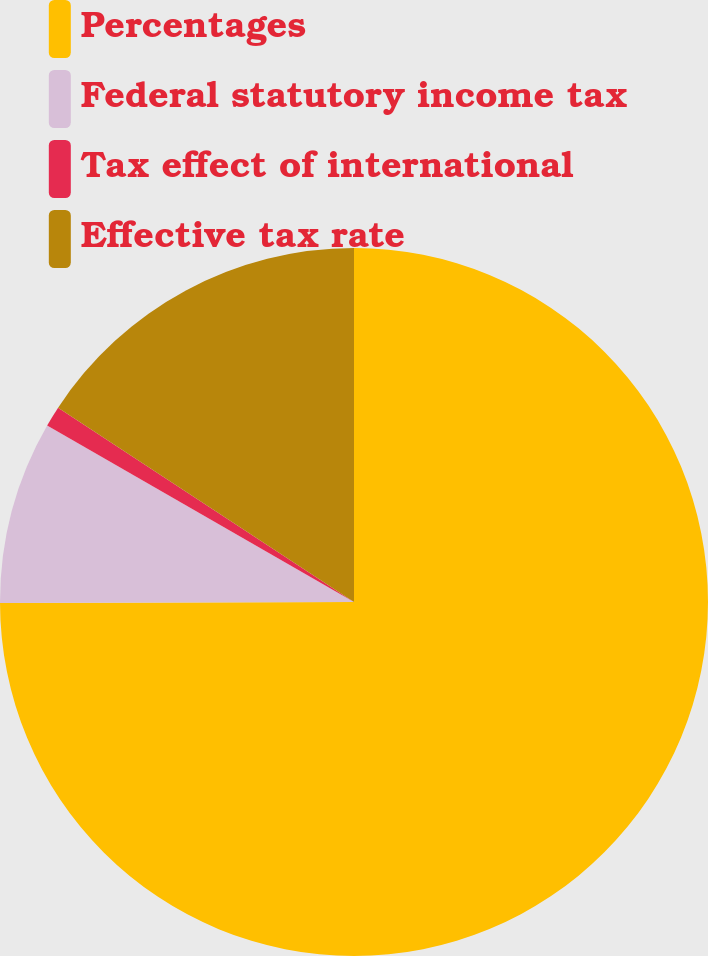Convert chart. <chart><loc_0><loc_0><loc_500><loc_500><pie_chart><fcel>Percentages<fcel>Federal statutory income tax<fcel>Tax effect of international<fcel>Effective tax rate<nl><fcel>74.96%<fcel>8.35%<fcel>0.94%<fcel>15.75%<nl></chart> 